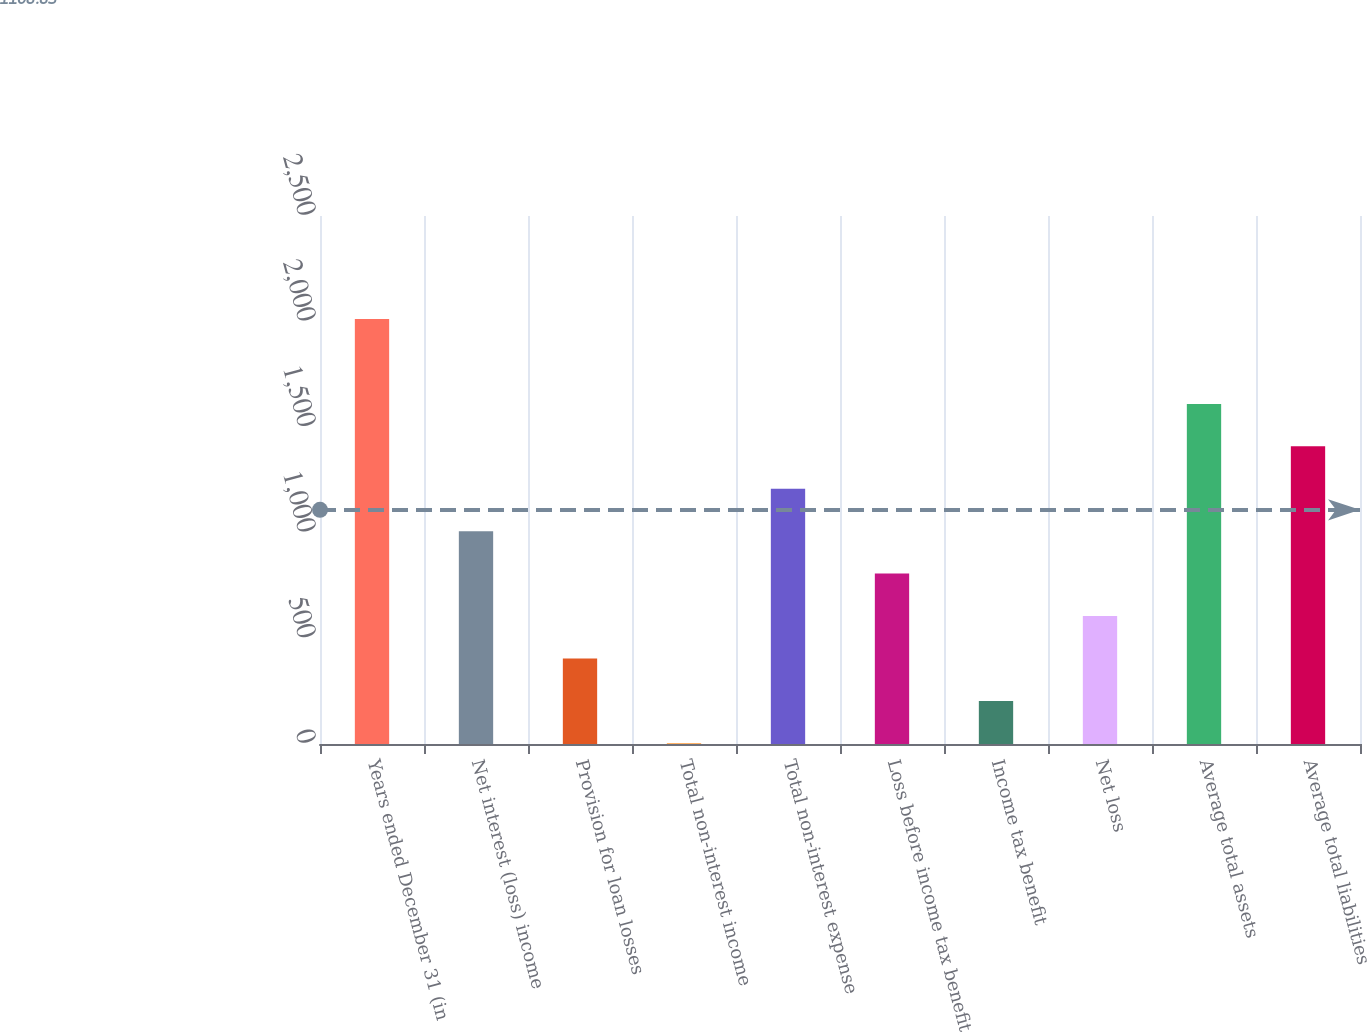Convert chart to OTSL. <chart><loc_0><loc_0><loc_500><loc_500><bar_chart><fcel>Years ended December 31 (in<fcel>Net interest (loss) income<fcel>Provision for loan losses<fcel>Total non-interest income<fcel>Total non-interest expense<fcel>Loss before income tax benefit<fcel>Income tax benefit<fcel>Net loss<fcel>Average total assets<fcel>Average total liabilities<nl><fcel>2012<fcel>1007.6<fcel>404.96<fcel>3.2<fcel>1208.48<fcel>806.72<fcel>204.08<fcel>605.84<fcel>1610.24<fcel>1409.36<nl></chart> 